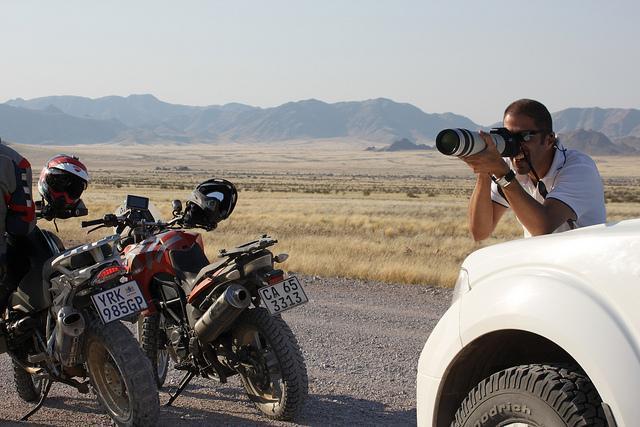How many motorcycles are parked?
Give a very brief answer. 2. How many people can you see?
Give a very brief answer. 1. How many motorcycles can be seen?
Give a very brief answer. 2. 